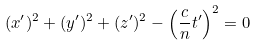<formula> <loc_0><loc_0><loc_500><loc_500>( x ^ { \prime } ) ^ { 2 } + ( y ^ { \prime } ) ^ { 2 } + ( z ^ { \prime } ) ^ { 2 } - \left ( \frac { c } { n } t ^ { \prime } \right ) ^ { 2 } = 0</formula> 